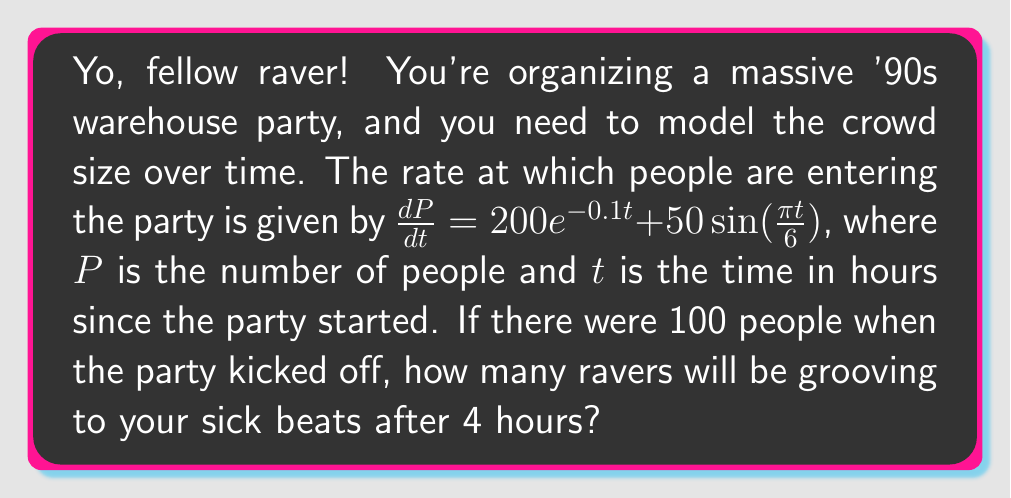Solve this math problem. Alright, let's break this down, old-school style:

1) We've got a first-order differential equation:

   $\frac{dP}{dt} = 200e^{-0.1t} + 50\sin(\frac{\pi t}{6})$

2) To find the number of people after 4 hours, we need to integrate this equation from $t=0$ to $t=4$:

   $P(4) - P(0) = \int_0^4 (200e^{-0.1t} + 50\sin(\frac{\pi t}{6})) dt$

3) Let's integrate the exponential part first:

   $\int 200e^{-0.1t} dt = -2000e^{-0.1t} + C$

4) Now the sine part:

   $\int 50\sin(\frac{\pi t}{6}) dt = -300\cos(\frac{\pi t}{6}) + C$

5) Putting it all together:

   $P(4) - P(0) = [-2000e^{-0.1t} - 300\cos(\frac{\pi t}{6})]_0^4$

6) Evaluate at the limits:

   $P(4) - P(0) = [-2000e^{-0.4} - 300\cos(\frac{2\pi}{3})] - [-2000 - 300]$
                 $= [-1340.1 + 150] - [-2300]$
                 $= 1109.9$

7) We know $P(0) = 100$, so:

   $P(4) = 1109.9 + 100 = 1209.9$

8) Rounding to the nearest person:

   $P(4) \approx 1210$ people
Answer: After 4 hours, there will be approximately 1210 ravers at your '90s warehouse party. 